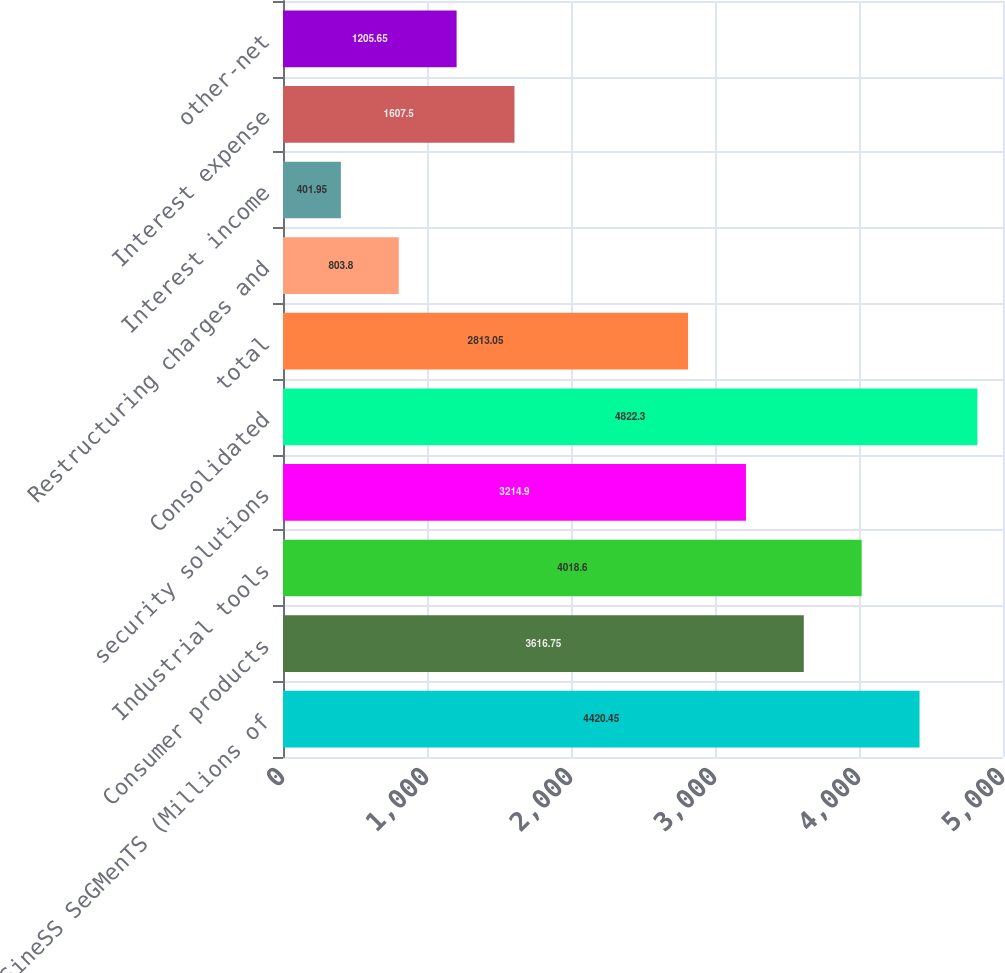Convert chart to OTSL. <chart><loc_0><loc_0><loc_500><loc_500><bar_chart><fcel>buSineSS SeGMenTS (Millions of<fcel>Consumer products<fcel>Industrial tools<fcel>security solutions<fcel>Consolidated<fcel>total<fcel>Restructuring charges and<fcel>Interest income<fcel>Interest expense<fcel>other-net<nl><fcel>4420.45<fcel>3616.75<fcel>4018.6<fcel>3214.9<fcel>4822.3<fcel>2813.05<fcel>803.8<fcel>401.95<fcel>1607.5<fcel>1205.65<nl></chart> 